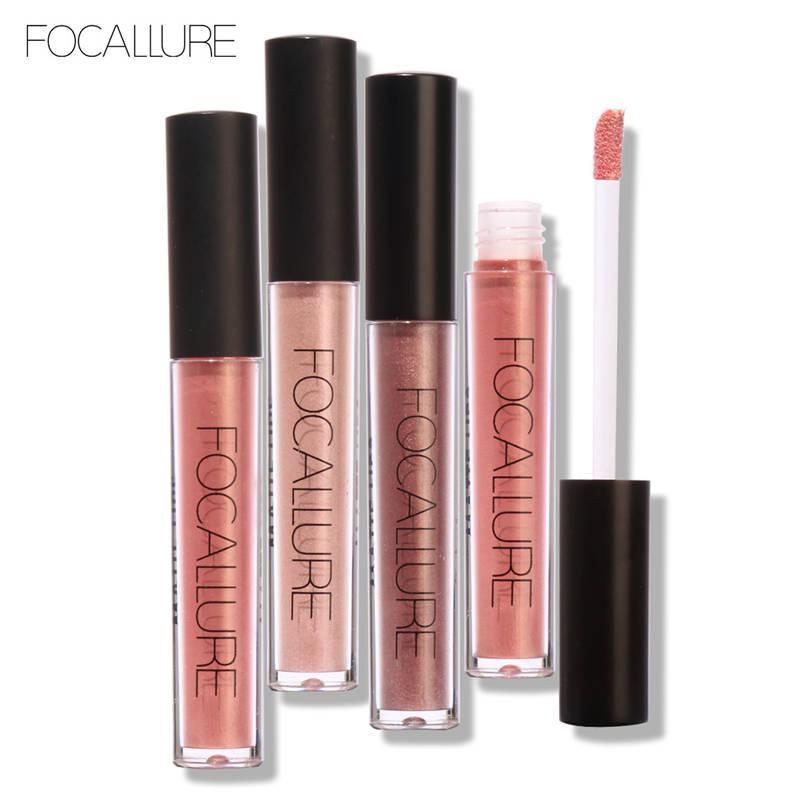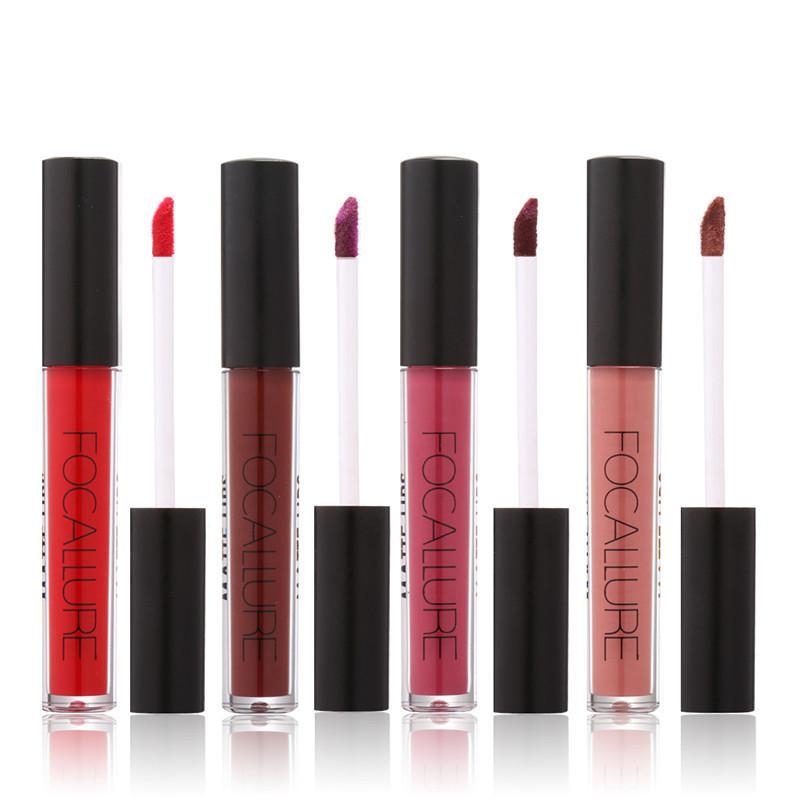The first image is the image on the left, the second image is the image on the right. Assess this claim about the two images: "An image shows a row of three items, including a narrow box.". Correct or not? Answer yes or no. No. The first image is the image on the left, the second image is the image on the right. Assess this claim about the two images: "There is a square container of makeup.". Correct or not? Answer yes or no. No. 